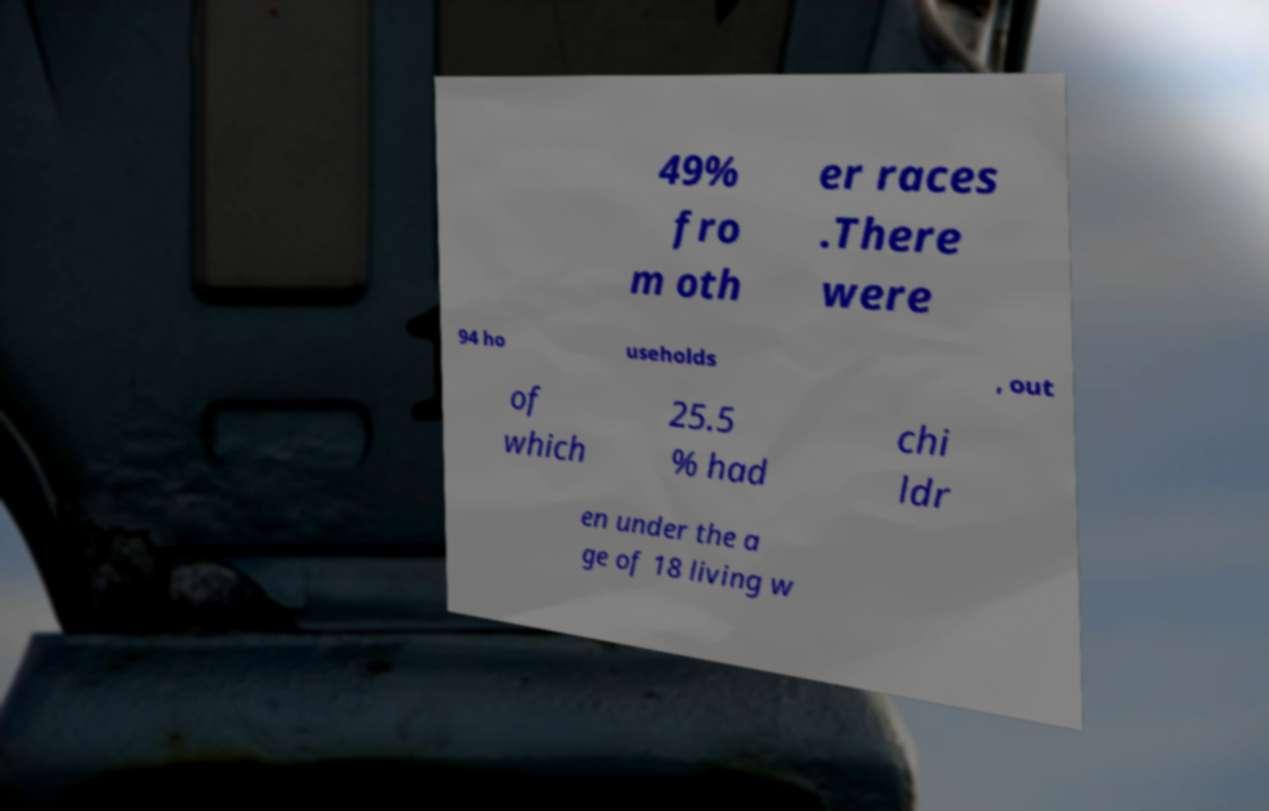Could you assist in decoding the text presented in this image and type it out clearly? 49% fro m oth er races .There were 94 ho useholds , out of which 25.5 % had chi ldr en under the a ge of 18 living w 